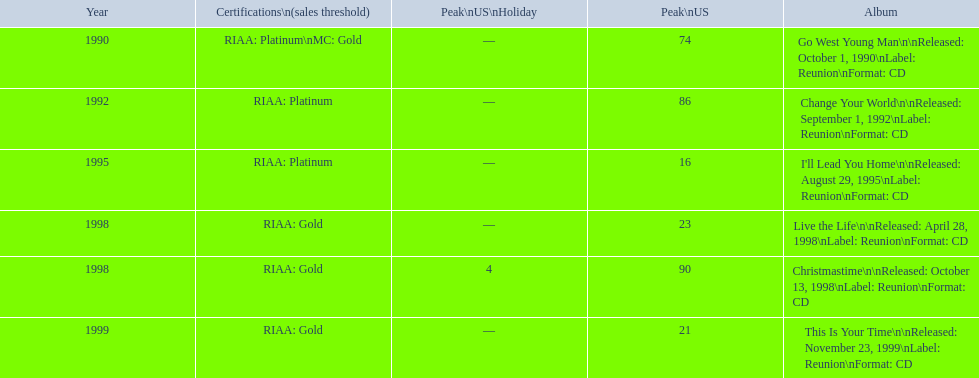How many songs are listed from 1998? 2. 